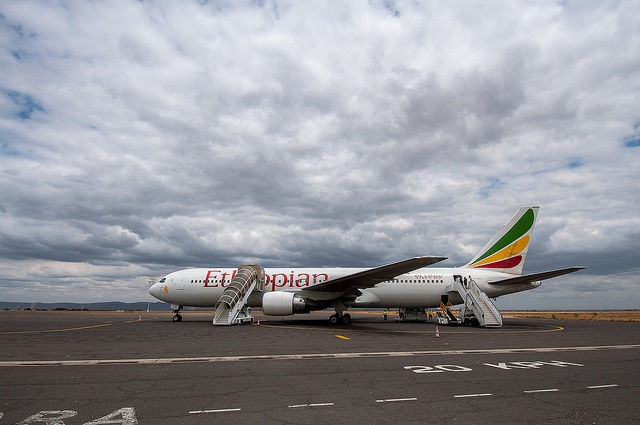Describe the objects in this image and their specific colors. I can see a airplane in darkgray, black, lightgray, and gray tones in this image. 